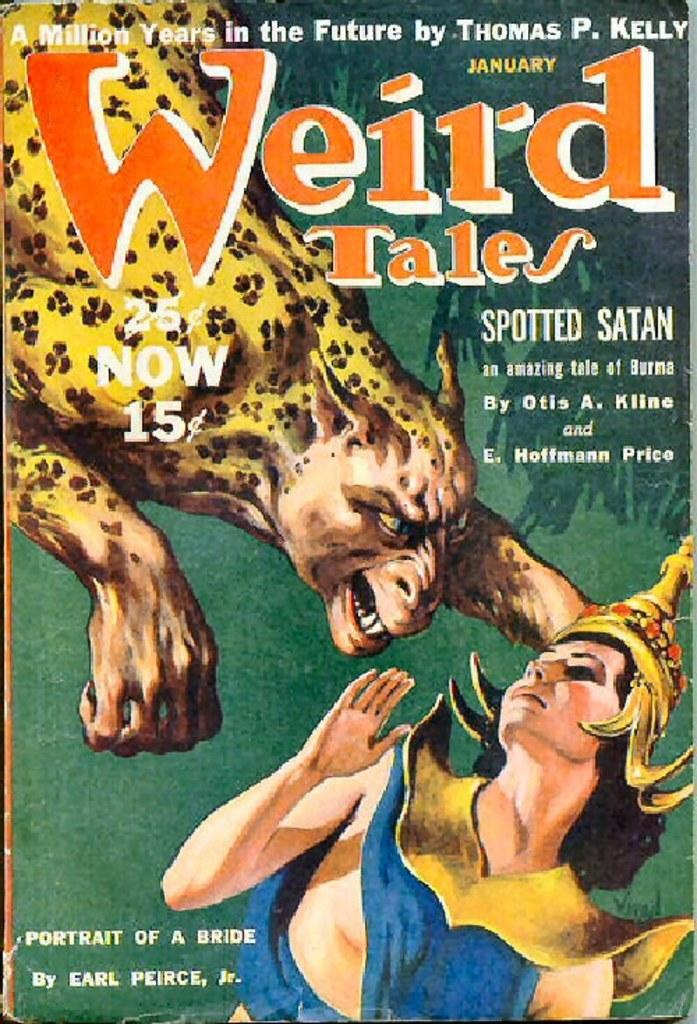Provide a one-sentence caption for the provided image. A page titled Weird Tales with the art being done by Earl Pierce. 